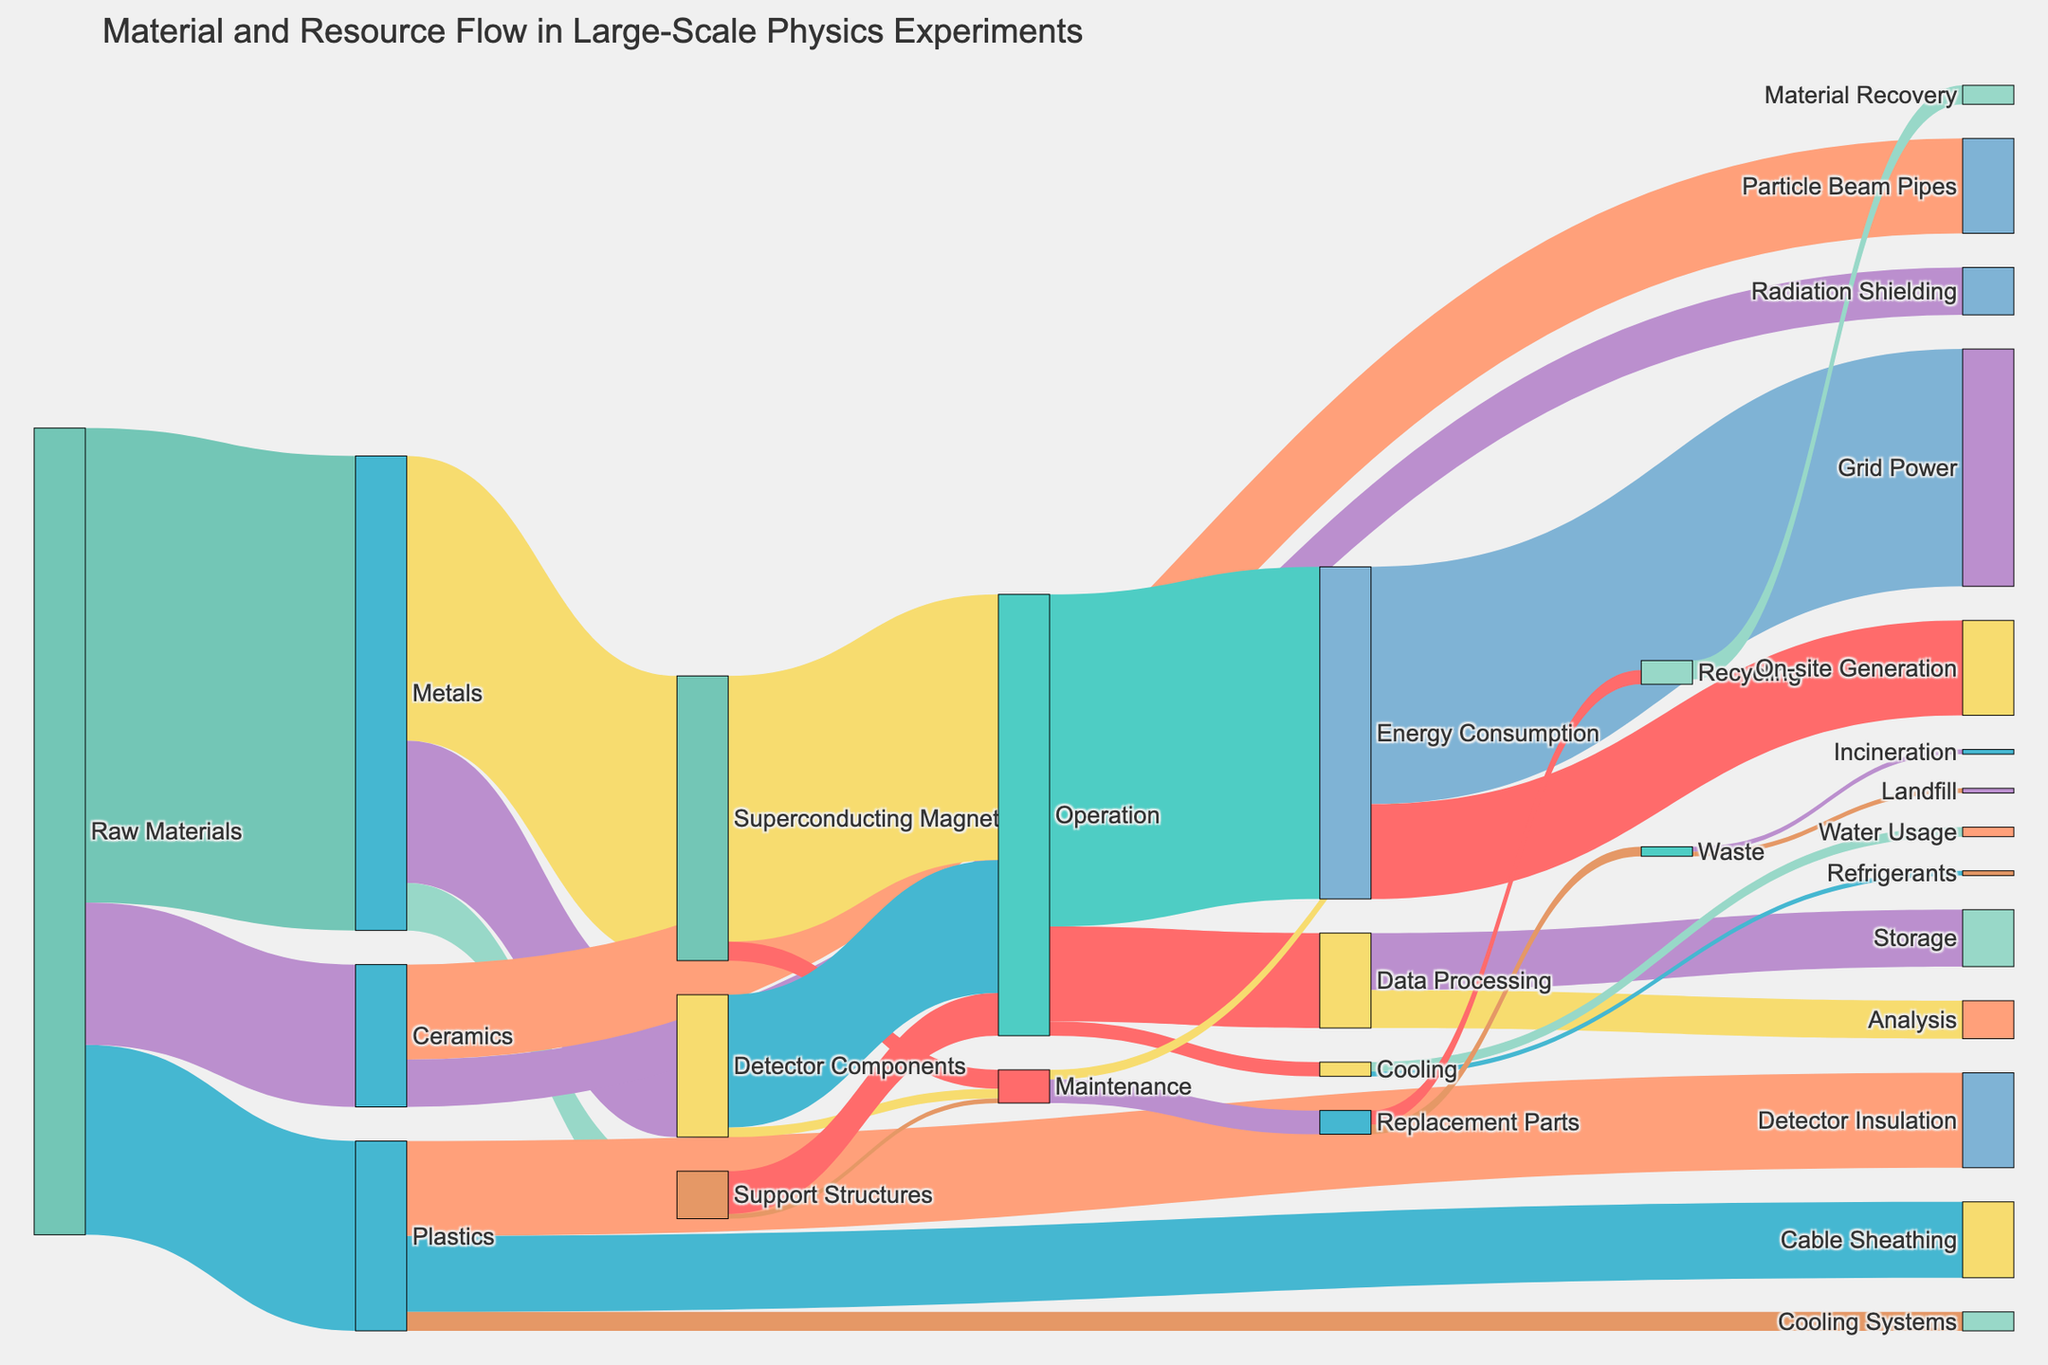How much raw metal is used in total for different components? The flow from Raw Materials to Metals shows 5000 units, which are then divided into Superconducting Magnets (3000 units), Detector Components (1500 units), and Support Structures (500 units). The total usage sums up to 3000 + 1500 + 500 = 5000 units.
Answer: 5000 units Which component among the Superconducting Magnets, Detector Components, and Support Structures uses the most energy during operation? The flow from Operation to different components shows Energy Consumption for Superconducting Magnets (2800 units), Detector Components (1400 units), and Support Structures (450 units). Superconducting Magnets use the most energy with 2800 units.
Answer: Superconducting Magnets How much total waste is produced from Replacement Parts? The Replacement Parts contribute to Recycling (150 units) and Waste (100 units). To find the total waste, sum these up: 150 + 100 = 250 units.
Answer: 250 units What is the biggest contributor to the Data Processing flow? Data Processing has contributions from Storage (600 units) and Analysis (400 units). Storage with 600 units is the largest contributor.
Answer: Storage Compare the flow of Plastics going into Detector Insulation and Cable Sheathing. Which one is higher? Plastics are consumed by Detector Insulation (1000 units) and Cable Sheathing (800 units). Detector Insulation has a higher flow at 1000 units.
Answer: Detector Insulation What is the final destination of Grid Power from Energy Consumption? Energy Consumption splits into Grid Power (2500 units) and On-site Generation (1000 units). Grid Power does not split further and is consumed entirely as it is.
Answer: Grid Power What amount of raw materials is directed toward Radiation Shielding? The flow shows Raw Materials going to Ceramics, of which 500 units are directed towards Radiation Shielding.
Answer: 500 units Which process uses less energy, Operation or Data Processing? The flow indicates that Operation uses 3500 units and Data Processing uses 1000 units. Data Processing uses less energy.
Answer: Data Processing How much Water Usage is there in relation to Cooling Systems? The flow from Cooling to Water Usage shows 100 units used.
Answer: 100 units Identify the major use of ceramics in the construction phase. Ceramics are used in Particle Beam Pipes (1000 units) and Radiation Shielding (500 units). Particle Beam Pipes are the major use with 1000 units.
Answer: Particle Beam Pipes 